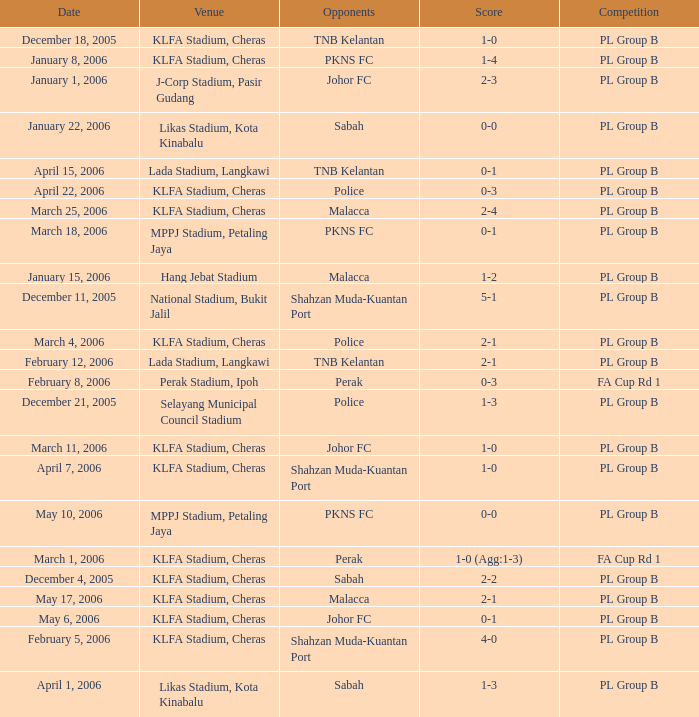Which Competition has a Score of 0-1, and Opponents of pkns fc? PL Group B. 